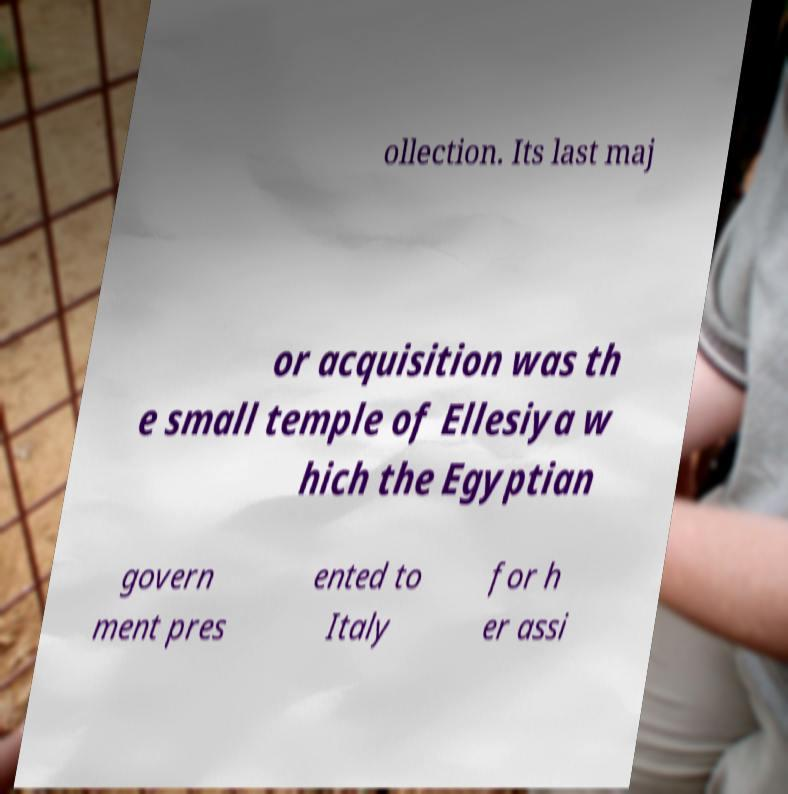Please read and relay the text visible in this image. What does it say? ollection. Its last maj or acquisition was th e small temple of Ellesiya w hich the Egyptian govern ment pres ented to Italy for h er assi 